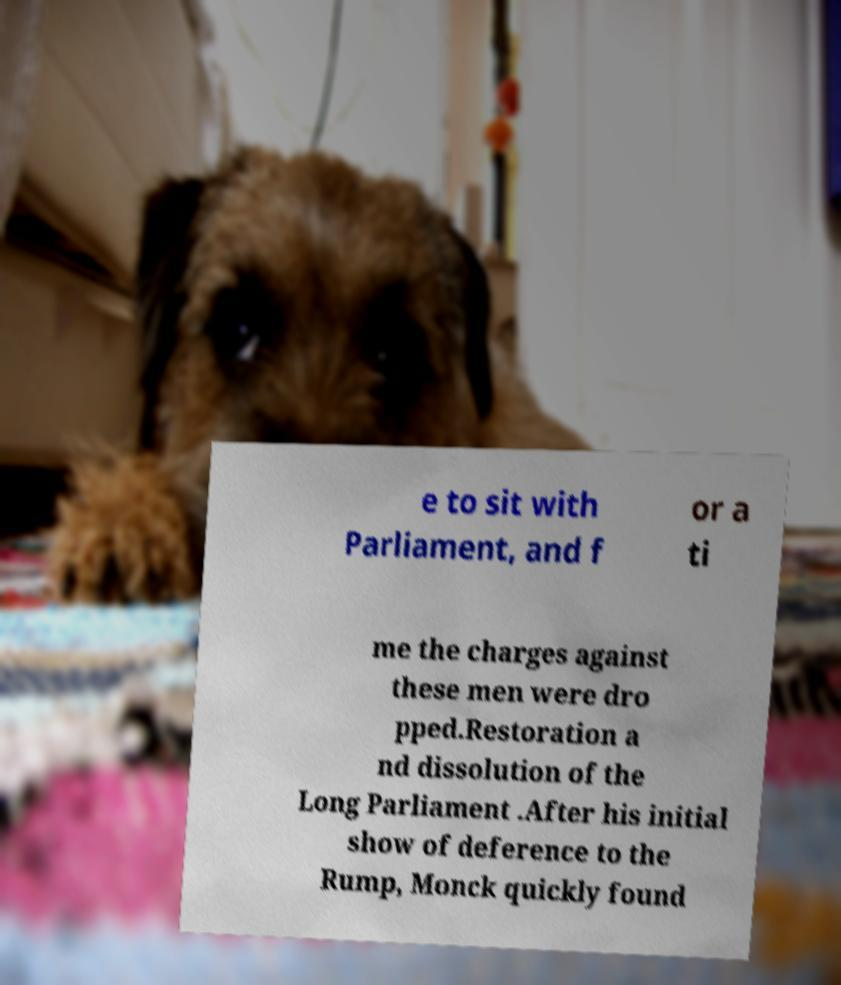For documentation purposes, I need the text within this image transcribed. Could you provide that? e to sit with Parliament, and f or a ti me the charges against these men were dro pped.Restoration a nd dissolution of the Long Parliament .After his initial show of deference to the Rump, Monck quickly found 